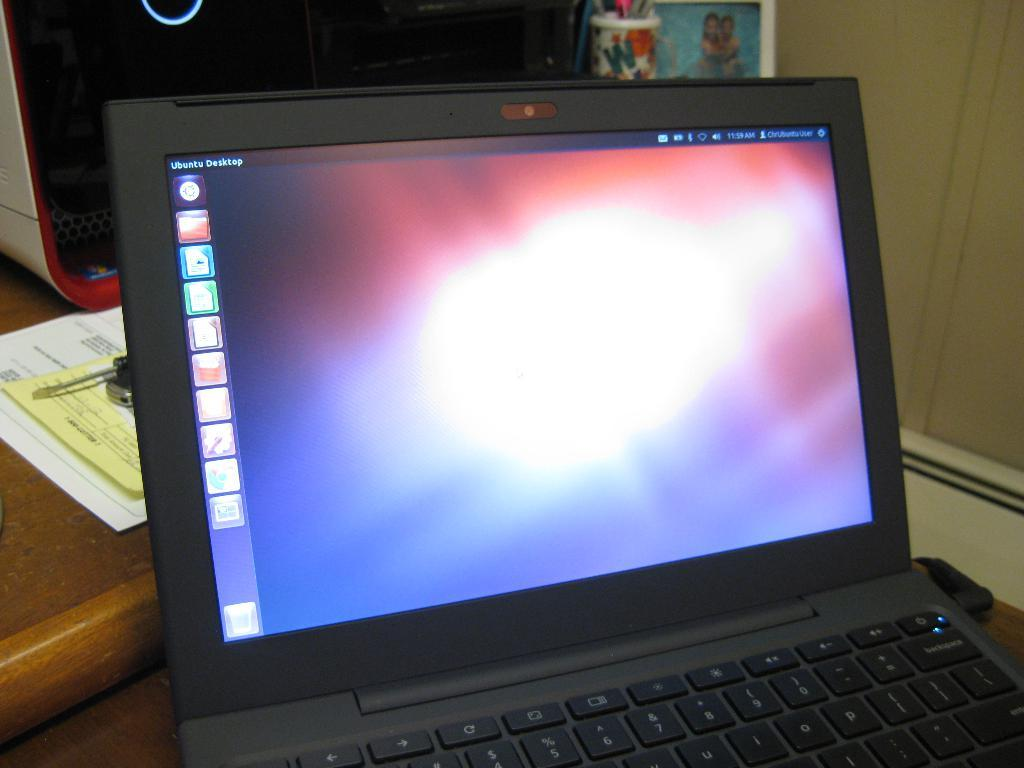<image>
Give a short and clear explanation of the subsequent image. the word desktop is on the laptop on the table 